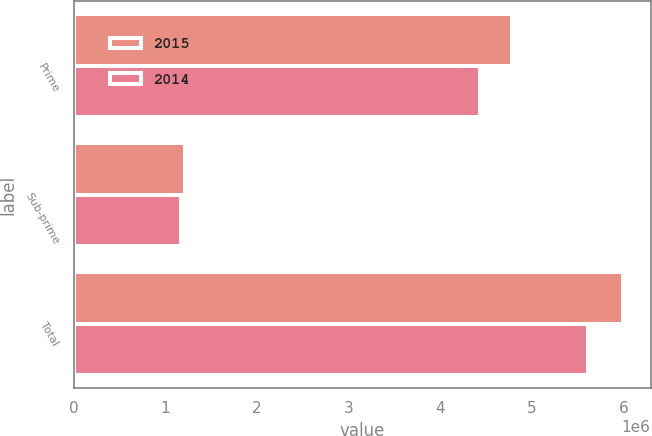Convert chart to OTSL. <chart><loc_0><loc_0><loc_500><loc_500><stacked_bar_chart><ecel><fcel>Prime<fcel>Sub-prime<fcel>Total<nl><fcel>2015<fcel>4.77745e+06<fcel>1.21402e+06<fcel>5.99147e+06<nl><fcel>2014<fcel>4.43535e+06<fcel>1.17257e+06<fcel>5.60792e+06<nl></chart> 